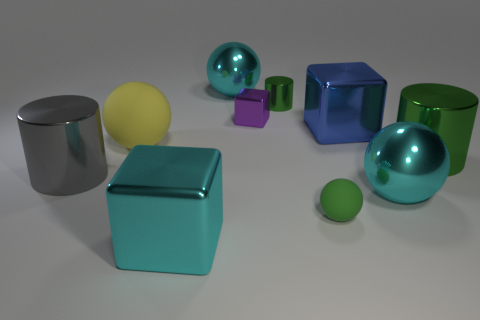Are there any yellow metallic cylinders?
Offer a terse response. No. There is a large green object; is it the same shape as the cyan object behind the big gray shiny cylinder?
Provide a succinct answer. No. What color is the tiny object in front of the large cylinder to the left of the big cyan object in front of the small green ball?
Your response must be concise. Green. There is a big yellow thing; are there any green metal cylinders behind it?
Your response must be concise. Yes. There is a metal thing that is the same color as the tiny metal cylinder; what is its size?
Keep it short and to the point. Large. Is there a blue object made of the same material as the tiny green cylinder?
Give a very brief answer. Yes. What color is the large rubber ball?
Give a very brief answer. Yellow. Is the shape of the large object that is behind the blue thing the same as  the yellow rubber thing?
Your answer should be compact. Yes. The large metallic object on the left side of the large matte object that is behind the big sphere to the right of the blue thing is what shape?
Your answer should be compact. Cylinder. There is a gray cylinder to the left of the tiny green rubber sphere; what material is it?
Offer a very short reply. Metal. 